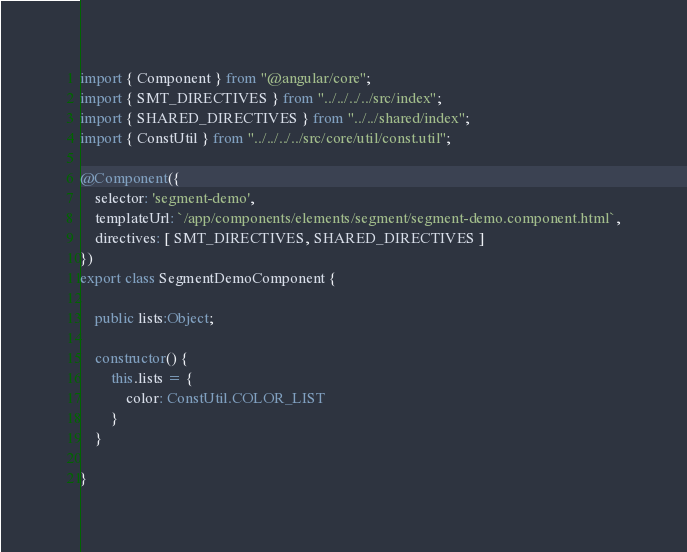<code> <loc_0><loc_0><loc_500><loc_500><_TypeScript_>import { Component } from "@angular/core";
import { SMT_DIRECTIVES } from "../../../../src/index";
import { SHARED_DIRECTIVES } from "../../shared/index";
import { ConstUtil } from "../../../../src/core/util/const.util";

@Component({
    selector: 'segment-demo',
    templateUrl: `/app/components/elements/segment/segment-demo.component.html`,
    directives: [ SMT_DIRECTIVES, SHARED_DIRECTIVES ]
})
export class SegmentDemoComponent {

    public lists:Object;

    constructor() {
        this.lists = {
            color: ConstUtil.COLOR_LIST
        }
    }

}</code> 